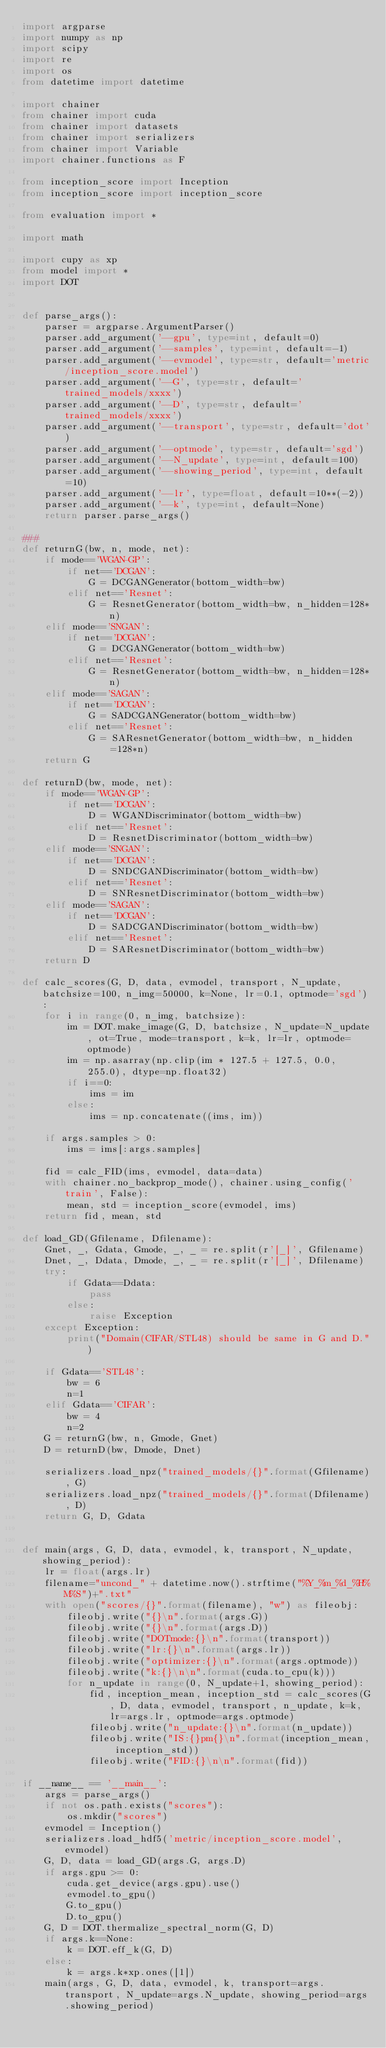<code> <loc_0><loc_0><loc_500><loc_500><_Python_>import argparse
import numpy as np
import scipy
import re
import os
from datetime import datetime

import chainer
from chainer import cuda
from chainer import datasets
from chainer import serializers
from chainer import Variable
import chainer.functions as F

from inception_score import Inception
from inception_score import inception_score

from evaluation import *

import math

import cupy as xp
from model import *
import DOT 


def parse_args():
    parser = argparse.ArgumentParser()
    parser.add_argument('--gpu', type=int, default=0)
    parser.add_argument('--samples', type=int, default=-1)
    parser.add_argument('--evmodel', type=str, default='metric/inception_score.model')
    parser.add_argument('--G', type=str, default='trained_models/xxxx')
    parser.add_argument('--D', type=str, default='trained_models/xxxx')
    parser.add_argument('--transport', type=str, default='dot')
    parser.add_argument('--optmode', type=str, default='sgd')
    parser.add_argument('--N_update', type=int, default=100)
    parser.add_argument('--showing_period', type=int, default=10)
    parser.add_argument('--lr', type=float, default=10**(-2))
    parser.add_argument('--k', type=int, default=None)
    return parser.parse_args()

###
def returnG(bw, n, mode, net):
    if mode=='WGAN-GP':
        if net=='DCGAN':
            G = DCGANGenerator(bottom_width=bw)
        elif net=='Resnet':
            G = ResnetGenerator(bottom_width=bw, n_hidden=128*n)
    elif mode=='SNGAN':
        if net=='DCGAN':
            G = DCGANGenerator(bottom_width=bw)
        elif net=='Resnet':
            G = ResnetGenerator(bottom_width=bw, n_hidden=128*n)
    elif mode=='SAGAN':
        if net=='DCGAN':
            G = SADCGANGenerator(bottom_width=bw)
        elif net=='Resnet':
            G = SAResnetGenerator(bottom_width=bw, n_hidden=128*n)
    return G

def returnD(bw, mode, net):
    if mode=='WGAN-GP':
        if net=='DCGAN':
            D = WGANDiscriminator(bottom_width=bw)
        elif net=='Resnet':
            D = ResnetDiscriminator(bottom_width=bw)
    elif mode=='SNGAN':
        if net=='DCGAN':
            D = SNDCGANDiscriminator(bottom_width=bw)
        elif net=='Resnet':
            D = SNResnetDiscriminator(bottom_width=bw)
    elif mode=='SAGAN':
        if net=='DCGAN':
            D = SADCGANDiscriminator(bottom_width=bw)
        elif net=='Resnet':
            D = SAResnetDiscriminator(bottom_width=bw)
    return D

def calc_scores(G, D, data, evmodel, transport, N_update, batchsize=100, n_img=50000, k=None, lr=0.1, optmode='sgd'):
    for i in range(0, n_img, batchsize):
        im = DOT.make_image(G, D, batchsize, N_update=N_update, ot=True, mode=transport, k=k, lr=lr, optmode=optmode)
        im = np.asarray(np.clip(im * 127.5 + 127.5, 0.0, 255.0), dtype=np.float32)
        if i==0:
            ims = im
        else:
            ims = np.concatenate((ims, im))

    if args.samples > 0:
        ims = ims[:args.samples]

    fid = calc_FID(ims, evmodel, data=data)
    with chainer.no_backprop_mode(), chainer.using_config('train', False):
        mean, std = inception_score(evmodel, ims)
    return fid, mean, std

def load_GD(Gfilename, Dfilename):
    Gnet, _, Gdata, Gmode, _, _ = re.split(r'[_]', Gfilename)
    Dnet, _, Ddata, Dmode, _, _ = re.split(r'[_]', Dfilename)
    try:
        if Gdata==Ddata:
            pass
        else:
            raise Exception
    except Exception:
        print("Domain(CIFAR/STL48) should be same in G and D.")

    if Gdata=='STL48':
        bw = 6
        n=1
    elif Gdata=='CIFAR':
        bw = 4
        n=2
    G = returnG(bw, n, Gmode, Gnet)
    D = returnD(bw, Dmode, Dnet)

    serializers.load_npz("trained_models/{}".format(Gfilename), G)
    serializers.load_npz("trained_models/{}".format(Dfilename), D)
    return G, D, Gdata


def main(args, G, D, data, evmodel, k, transport, N_update, showing_period):
    lr = float(args.lr)
    filename="uncond_" + datetime.now().strftime("%Y_%m_%d_%H%M%S")+".txt"
    with open("scores/{}".format(filename), "w") as fileobj:
        fileobj.write("{}\n".format(args.G))
        fileobj.write("{}\n".format(args.D))
        fileobj.write("DOTmode:{}\n".format(transport))
        fileobj.write("lr:{}\n".format(args.lr))
        fileobj.write("optimizer:{}\n".format(args.optmode))
        fileobj.write("k:{}\n\n".format(cuda.to_cpu(k)))
        for n_update in range(0, N_update+1, showing_period):
            fid, inception_mean, inception_std = calc_scores(G, D, data, evmodel, transport, n_update, k=k, lr=args.lr, optmode=args.optmode)
            fileobj.write("n_update:{}\n".format(n_update))
            fileobj.write("IS:{}pm{}\n".format(inception_mean, inception_std))
            fileobj.write("FID:{}\n\n".format(fid))

if __name__ == '__main__':
    args = parse_args()
    if not os.path.exists("scores"):
        os.mkdir("scores")
    evmodel = Inception()
    serializers.load_hdf5('metric/inception_score.model', evmodel)
    G, D, data = load_GD(args.G, args.D)
    if args.gpu >= 0:
        cuda.get_device(args.gpu).use()
        evmodel.to_gpu()
        G.to_gpu()
        D.to_gpu()
    G, D = DOT.thermalize_spectral_norm(G, D)
    if args.k==None:
        k = DOT.eff_k(G, D)
    else:
        k = args.k*xp.ones([1])
    main(args, G, D, data, evmodel, k, transport=args.transport, N_update=args.N_update, showing_period=args.showing_period)
</code> 